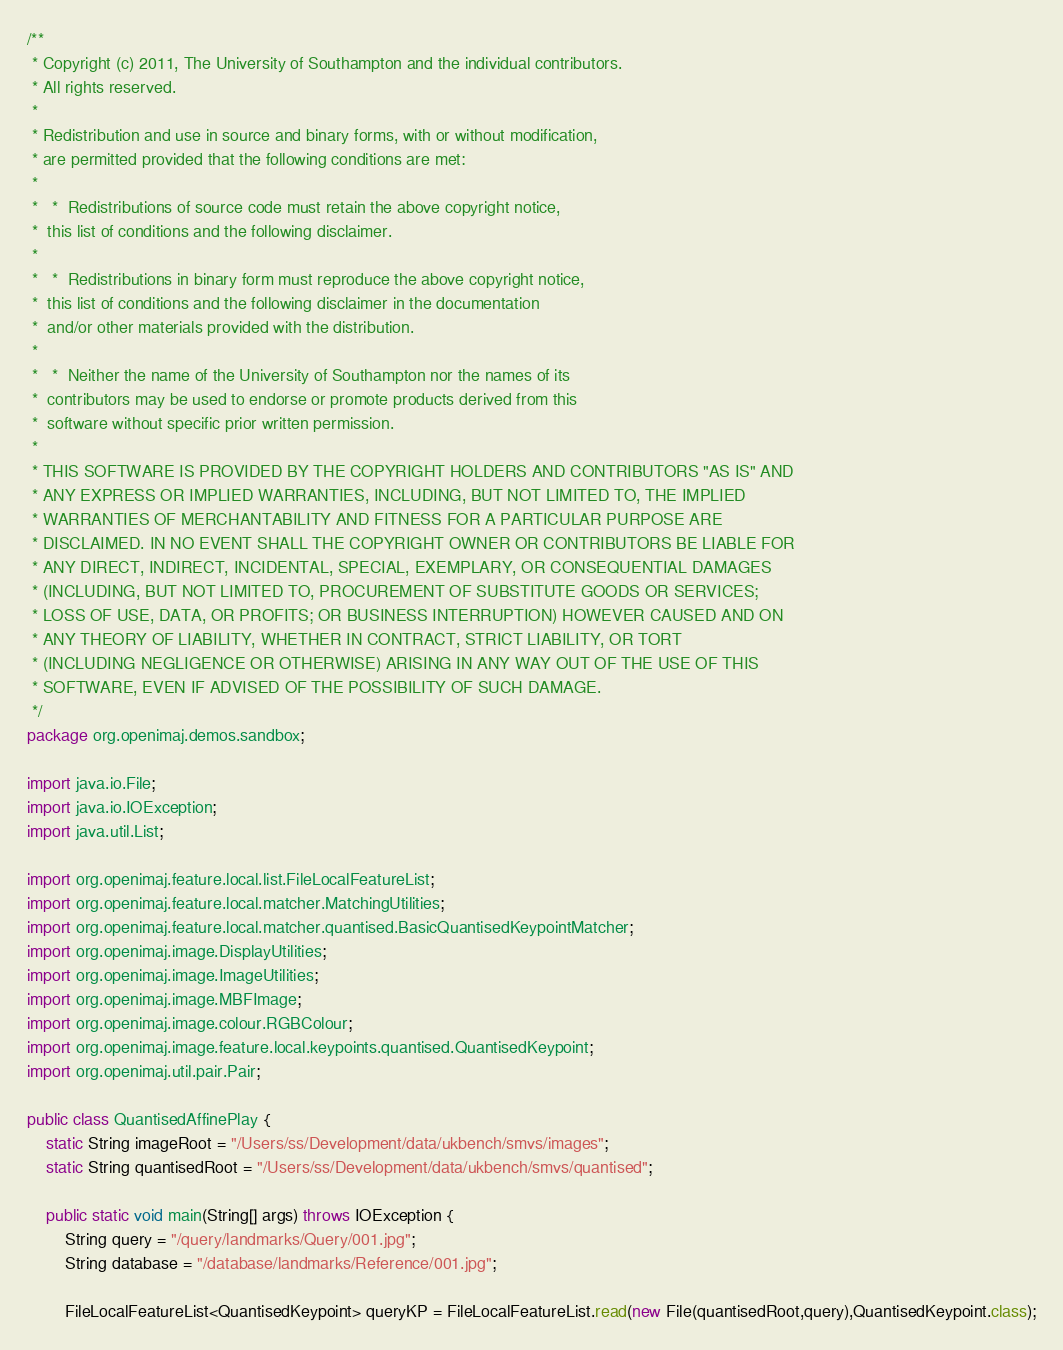Convert code to text. <code><loc_0><loc_0><loc_500><loc_500><_Java_>/**
 * Copyright (c) 2011, The University of Southampton and the individual contributors.
 * All rights reserved.
 *
 * Redistribution and use in source and binary forms, with or without modification,
 * are permitted provided that the following conditions are met:
 *
 *   * 	Redistributions of source code must retain the above copyright notice,
 * 	this list of conditions and the following disclaimer.
 *
 *   *	Redistributions in binary form must reproduce the above copyright notice,
 * 	this list of conditions and the following disclaimer in the documentation
 * 	and/or other materials provided with the distribution.
 *
 *   *	Neither the name of the University of Southampton nor the names of its
 * 	contributors may be used to endorse or promote products derived from this
 * 	software without specific prior written permission.
 *
 * THIS SOFTWARE IS PROVIDED BY THE COPYRIGHT HOLDERS AND CONTRIBUTORS "AS IS" AND
 * ANY EXPRESS OR IMPLIED WARRANTIES, INCLUDING, BUT NOT LIMITED TO, THE IMPLIED
 * WARRANTIES OF MERCHANTABILITY AND FITNESS FOR A PARTICULAR PURPOSE ARE
 * DISCLAIMED. IN NO EVENT SHALL THE COPYRIGHT OWNER OR CONTRIBUTORS BE LIABLE FOR
 * ANY DIRECT, INDIRECT, INCIDENTAL, SPECIAL, EXEMPLARY, OR CONSEQUENTIAL DAMAGES
 * (INCLUDING, BUT NOT LIMITED TO, PROCUREMENT OF SUBSTITUTE GOODS OR SERVICES;
 * LOSS OF USE, DATA, OR PROFITS; OR BUSINESS INTERRUPTION) HOWEVER CAUSED AND ON
 * ANY THEORY OF LIABILITY, WHETHER IN CONTRACT, STRICT LIABILITY, OR TORT
 * (INCLUDING NEGLIGENCE OR OTHERWISE) ARISING IN ANY WAY OUT OF THE USE OF THIS
 * SOFTWARE, EVEN IF ADVISED OF THE POSSIBILITY OF SUCH DAMAGE.
 */
package org.openimaj.demos.sandbox;

import java.io.File;
import java.io.IOException;
import java.util.List;

import org.openimaj.feature.local.list.FileLocalFeatureList;
import org.openimaj.feature.local.matcher.MatchingUtilities;
import org.openimaj.feature.local.matcher.quantised.BasicQuantisedKeypointMatcher;
import org.openimaj.image.DisplayUtilities;
import org.openimaj.image.ImageUtilities;
import org.openimaj.image.MBFImage;
import org.openimaj.image.colour.RGBColour;
import org.openimaj.image.feature.local.keypoints.quantised.QuantisedKeypoint;
import org.openimaj.util.pair.Pair;

public class QuantisedAffinePlay {
	static String imageRoot = "/Users/ss/Development/data/ukbench/smvs/images";
	static String quantisedRoot = "/Users/ss/Development/data/ukbench/smvs/quantised";
	
	public static void main(String[] args) throws IOException {
		String query = "/query/landmarks/Query/001.jpg";
		String database = "/database/landmarks/Reference/001.jpg";
		
		FileLocalFeatureList<QuantisedKeypoint> queryKP = FileLocalFeatureList.read(new File(quantisedRoot,query),QuantisedKeypoint.class);</code> 